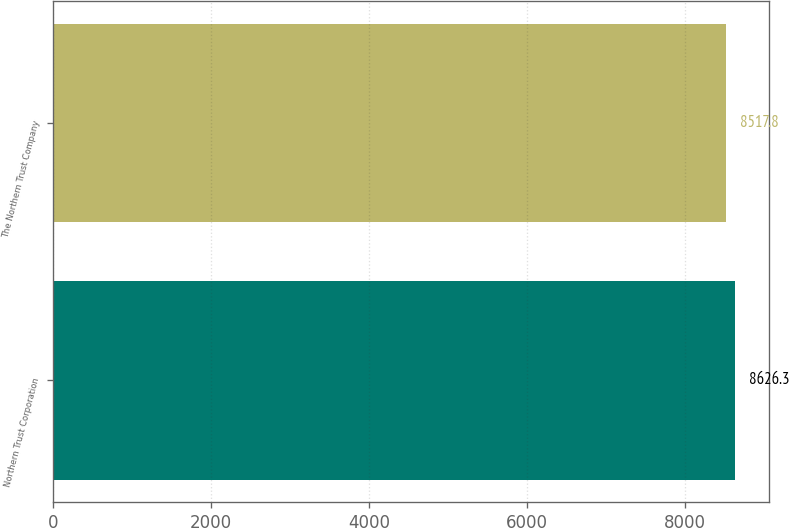Convert chart to OTSL. <chart><loc_0><loc_0><loc_500><loc_500><bar_chart><fcel>Northern Trust Corporation<fcel>The Northern Trust Company<nl><fcel>8626.3<fcel>8517.8<nl></chart> 